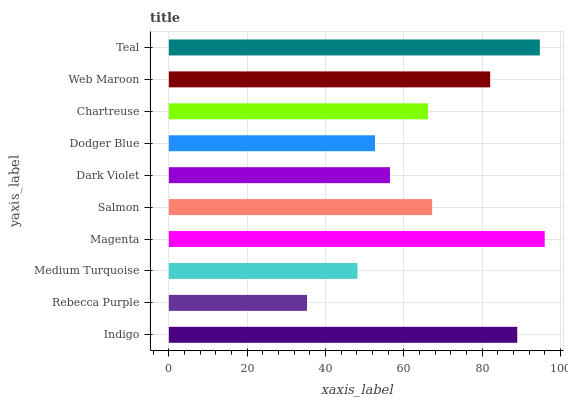Is Rebecca Purple the minimum?
Answer yes or no. Yes. Is Magenta the maximum?
Answer yes or no. Yes. Is Medium Turquoise the minimum?
Answer yes or no. No. Is Medium Turquoise the maximum?
Answer yes or no. No. Is Medium Turquoise greater than Rebecca Purple?
Answer yes or no. Yes. Is Rebecca Purple less than Medium Turquoise?
Answer yes or no. Yes. Is Rebecca Purple greater than Medium Turquoise?
Answer yes or no. No. Is Medium Turquoise less than Rebecca Purple?
Answer yes or no. No. Is Salmon the high median?
Answer yes or no. Yes. Is Chartreuse the low median?
Answer yes or no. Yes. Is Dark Violet the high median?
Answer yes or no. No. Is Teal the low median?
Answer yes or no. No. 